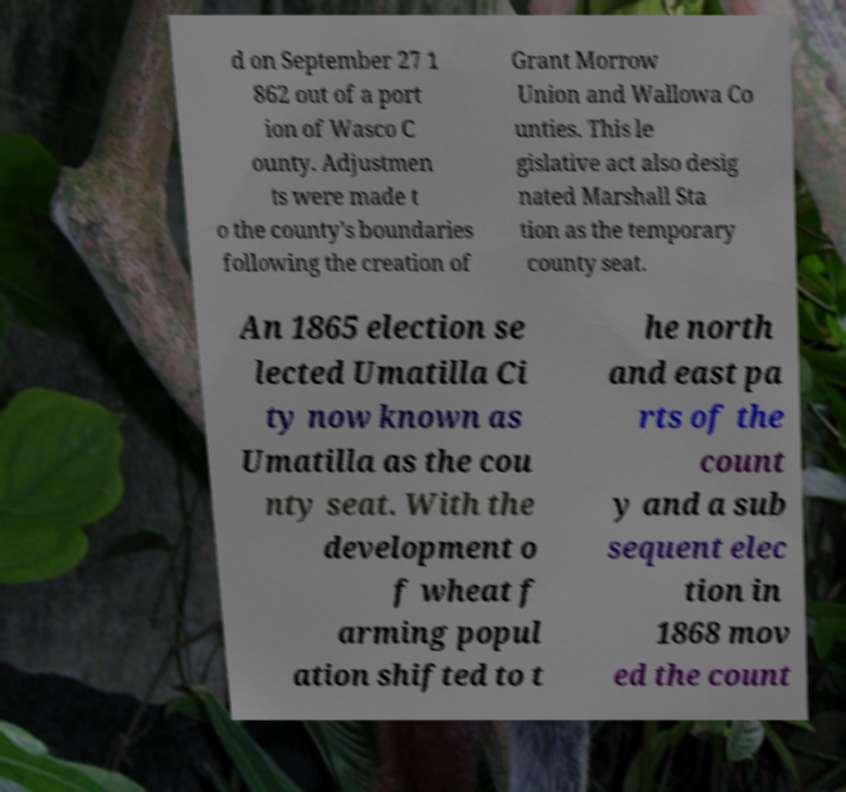What messages or text are displayed in this image? I need them in a readable, typed format. d on September 27 1 862 out of a port ion of Wasco C ounty. Adjustmen ts were made t o the county's boundaries following the creation of Grant Morrow Union and Wallowa Co unties. This le gislative act also desig nated Marshall Sta tion as the temporary county seat. An 1865 election se lected Umatilla Ci ty now known as Umatilla as the cou nty seat. With the development o f wheat f arming popul ation shifted to t he north and east pa rts of the count y and a sub sequent elec tion in 1868 mov ed the count 